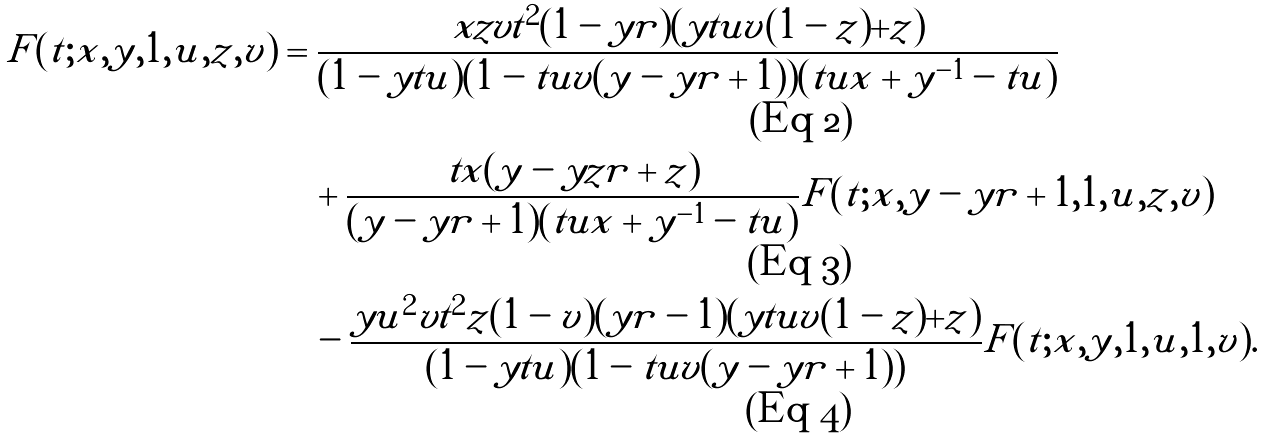<formula> <loc_0><loc_0><loc_500><loc_500>F ( t ; x , y , 1 , u , z , v ) & = \frac { x z v t ^ { 2 } ( 1 - y r ) ( y t u v ( 1 - z ) + z ) } { ( 1 - y t u ) ( 1 - t u v ( y - y r + 1 ) ) ( t u x + y ^ { - 1 } - t u ) } \\ & \quad + \frac { t x ( y - y z r + z ) } { ( y - y r + 1 ) ( t u x + y ^ { - 1 } - t u ) } F ( t ; x , y - y r + 1 , 1 , u , z , v ) \\ & \quad - \frac { y u ^ { 2 } v t ^ { 2 } z ( 1 - v ) ( y r - 1 ) ( y t u v ( 1 - z ) + z ) } { ( 1 - y t u ) ( 1 - t u v ( y - y r + 1 ) ) } F ( t ; x , y , 1 , u , 1 , v ) .</formula> 